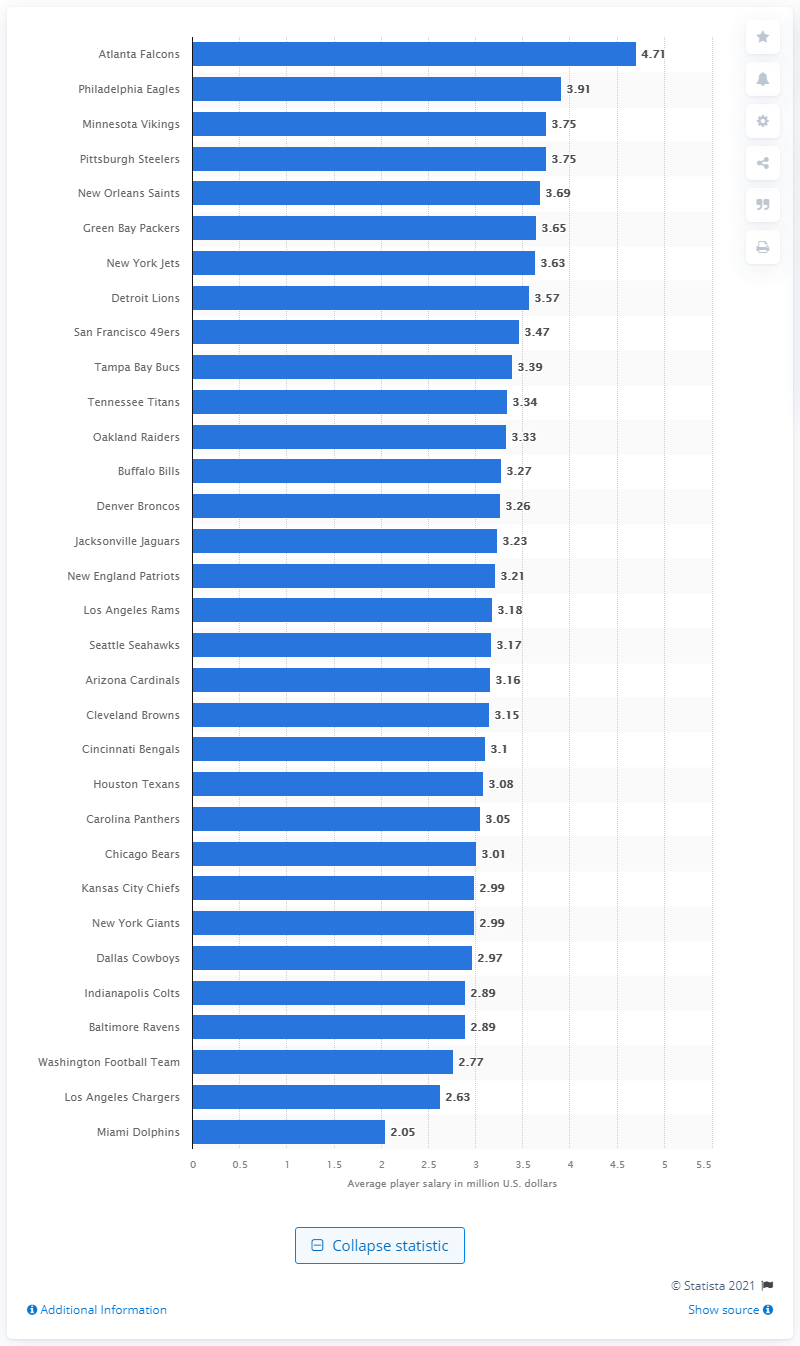Draw attention to some important aspects in this diagram. The average annual player salary for the Atlanta Falcons in 2019/2020 was $4.71 million. In the 2019/2020 season, the Miami Dolphins had the lowest wage bill among all teams. 